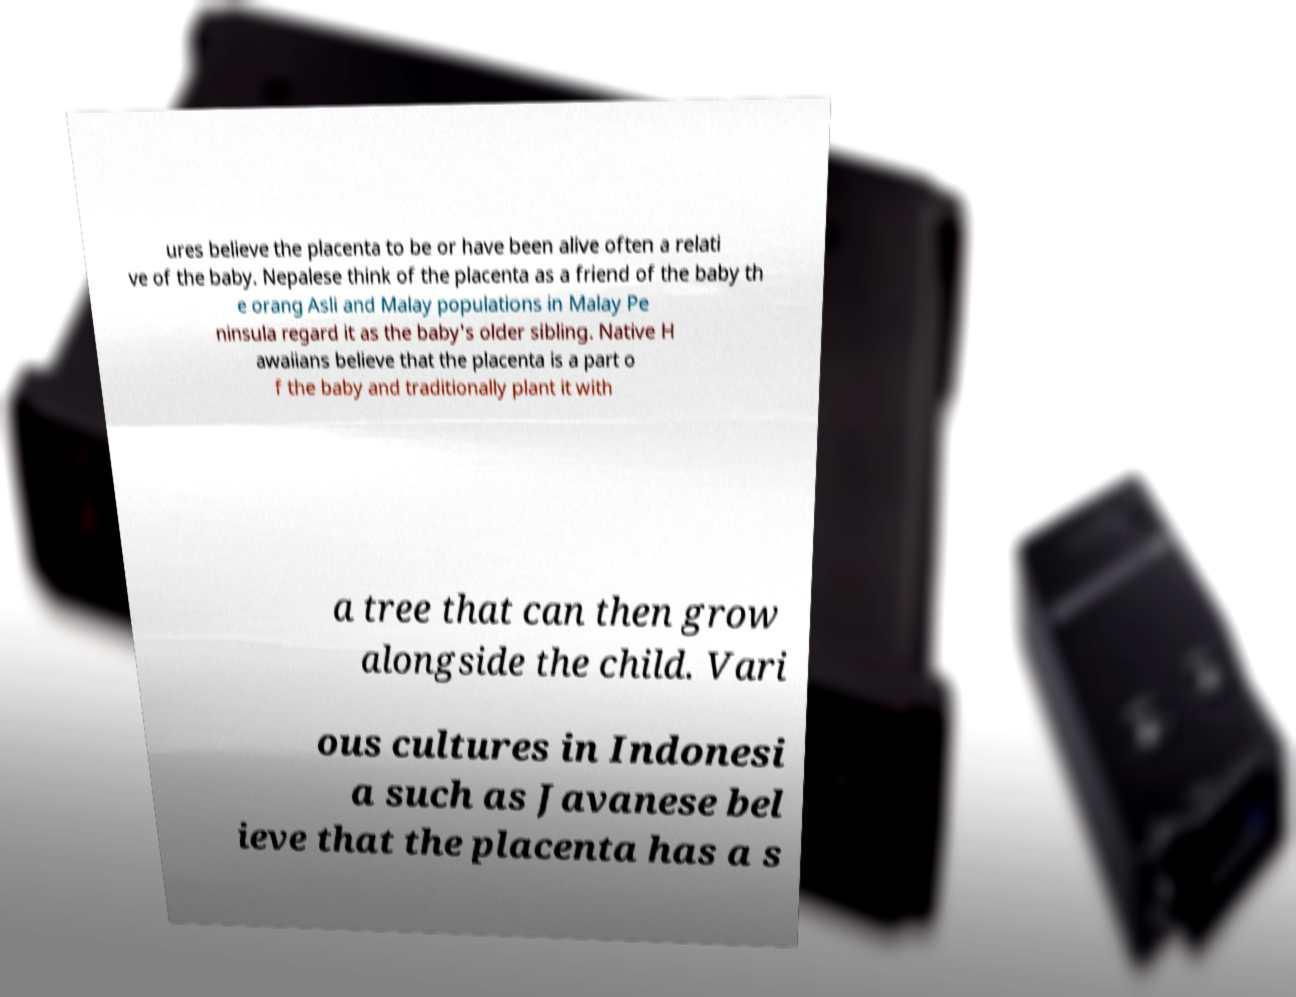Can you read and provide the text displayed in the image?This photo seems to have some interesting text. Can you extract and type it out for me? ures believe the placenta to be or have been alive often a relati ve of the baby. Nepalese think of the placenta as a friend of the baby th e orang Asli and Malay populations in Malay Pe ninsula regard it as the baby's older sibling. Native H awaiians believe that the placenta is a part o f the baby and traditionally plant it with a tree that can then grow alongside the child. Vari ous cultures in Indonesi a such as Javanese bel ieve that the placenta has a s 